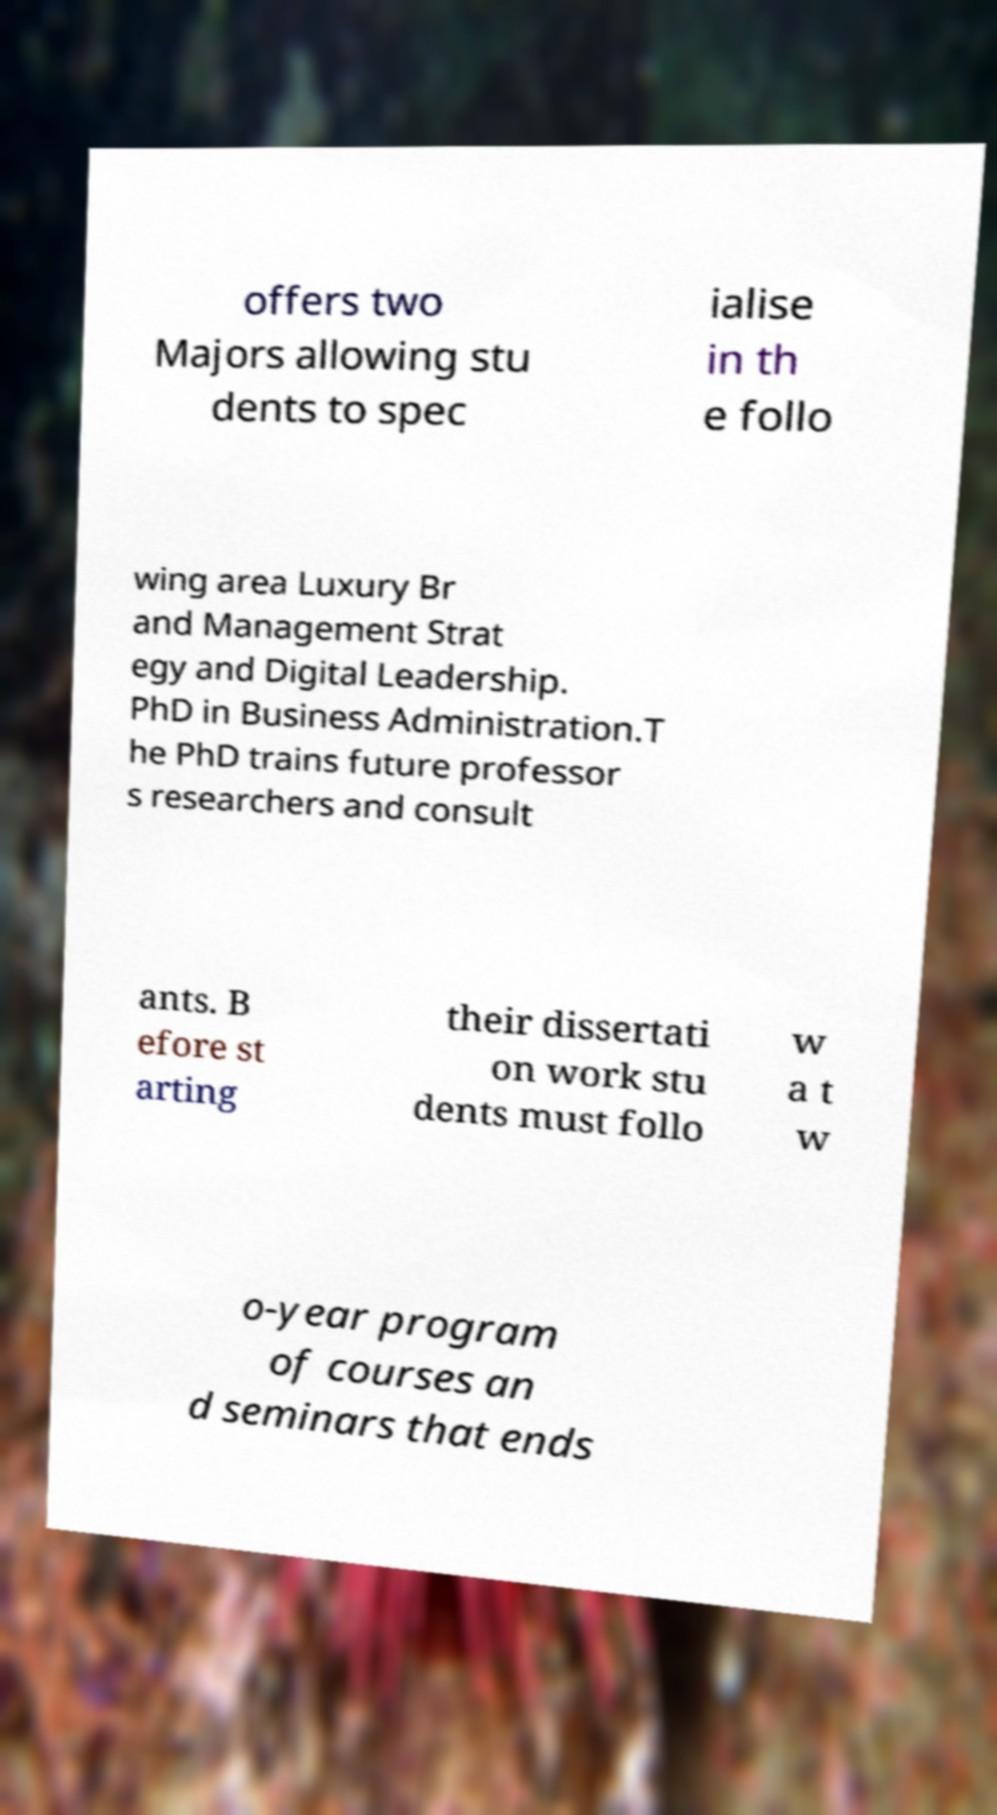Could you extract and type out the text from this image? offers two Majors allowing stu dents to spec ialise in th e follo wing area Luxury Br and Management Strat egy and Digital Leadership. PhD in Business Administration.T he PhD trains future professor s researchers and consult ants. B efore st arting their dissertati on work stu dents must follo w a t w o-year program of courses an d seminars that ends 